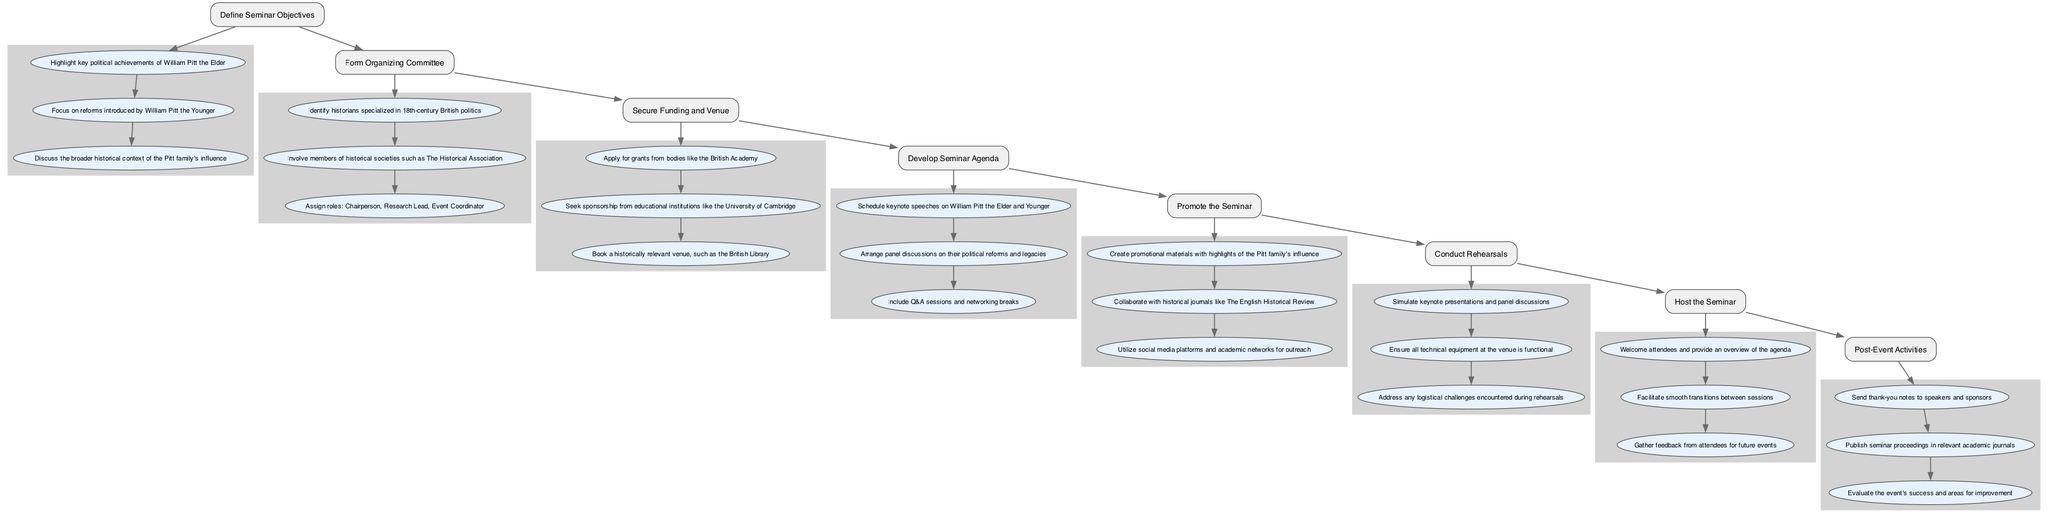What is the first step in organizing the seminar? The diagram shows "Define Seminar Objectives" as the first step, indicating that this is the initial phase of the seminar organization process.
Answer: Define Seminar Objectives How many substeps are there under "Form Organizing Committee"? The diagram lists three substeps under "Form Organizing Committee," which indicates the tasks involved in forming the committee.
Answer: 3 Which step follows "Secure Funding and Venue"? In the flowchart, "Develop Seminar Agenda" directly follows "Secure Funding and Venue," indicating the sequence of events in organizing the seminar.
Answer: Develop Seminar Agenda What is the last step of the seminar organization process? The final step in the flowchart is "Post-Event Activities," marking the concluding phase of the seminar organization process.
Answer: Post-Event Activities What type of venue is suggested in the "Secure Funding and Venue" step? The diagram suggests booking a "historically relevant venue," which reflects the focus of the seminar on historical themes.
Answer: Historically relevant venue Which substep comes after "Schedule keynote speeches on William Pitt the Elder and Younger"? The flowchart indicates that "Arrange panel discussions on their political reforms and legacies" is the substep that follows the scheduling of keynote speeches in the agenda development.
Answer: Arrange panel discussions on their political reforms and legacies How many main steps are shown in the diagram? The diagram outlines a total of eight main steps from defining objectives to post-event activities, showing the entire flow of organizing the seminar.
Answer: 8 Which committee member role is responsible for event management? The "Event Coordinator" is the specified role responsible for managing the seminar events, as indicated in the substeps of forming the organizing committee.
Answer: Event Coordinator What should be included in the promotion materials according to the "Promote the Seminar" step? The diagram indicates that promotional materials should contain "highlights of the Pitt family's influence," underlining the focus of the seminar promotion.
Answer: Highlights of the Pitt family's influence 